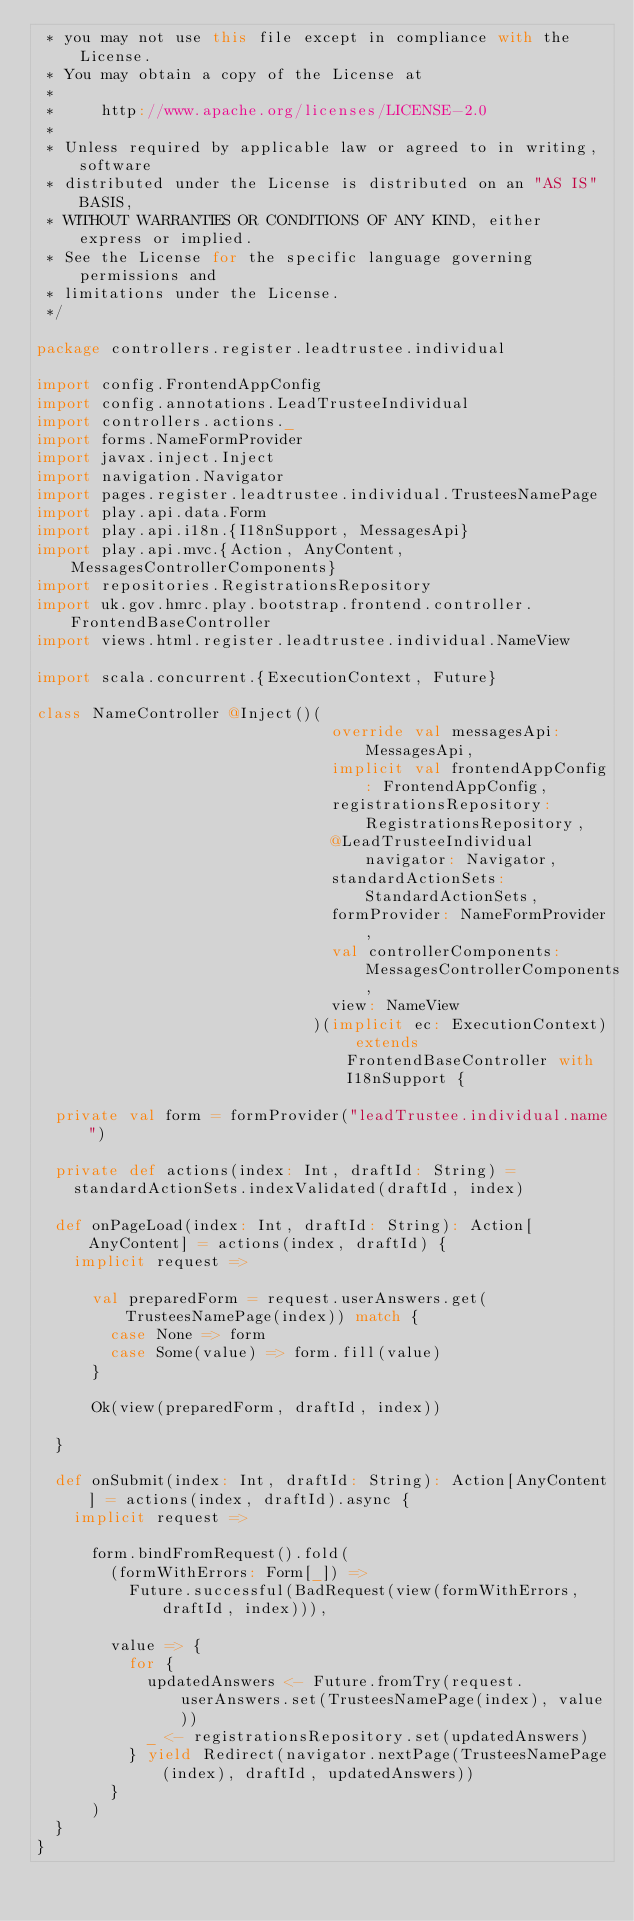Convert code to text. <code><loc_0><loc_0><loc_500><loc_500><_Scala_> * you may not use this file except in compliance with the License.
 * You may obtain a copy of the License at
 *
 *     http://www.apache.org/licenses/LICENSE-2.0
 *
 * Unless required by applicable law or agreed to in writing, software
 * distributed under the License is distributed on an "AS IS" BASIS,
 * WITHOUT WARRANTIES OR CONDITIONS OF ANY KIND, either express or implied.
 * See the License for the specific language governing permissions and
 * limitations under the License.
 */

package controllers.register.leadtrustee.individual

import config.FrontendAppConfig
import config.annotations.LeadTrusteeIndividual
import controllers.actions._
import forms.NameFormProvider
import javax.inject.Inject
import navigation.Navigator
import pages.register.leadtrustee.individual.TrusteesNamePage
import play.api.data.Form
import play.api.i18n.{I18nSupport, MessagesApi}
import play.api.mvc.{Action, AnyContent, MessagesControllerComponents}
import repositories.RegistrationsRepository
import uk.gov.hmrc.play.bootstrap.frontend.controller.FrontendBaseController
import views.html.register.leadtrustee.individual.NameView

import scala.concurrent.{ExecutionContext, Future}

class NameController @Inject()(
                                override val messagesApi: MessagesApi,
                                implicit val frontendAppConfig: FrontendAppConfig,
                                registrationsRepository: RegistrationsRepository,
                                @LeadTrusteeIndividual navigator: Navigator,
                                standardActionSets: StandardActionSets,
                                formProvider: NameFormProvider,
                                val controllerComponents: MessagesControllerComponents,
                                view: NameView
                              )(implicit ec: ExecutionContext) extends FrontendBaseController with I18nSupport {

  private val form = formProvider("leadTrustee.individual.name")

  private def actions(index: Int, draftId: String) =
    standardActionSets.indexValidated(draftId, index)

  def onPageLoad(index: Int, draftId: String): Action[AnyContent] = actions(index, draftId) {
    implicit request =>

      val preparedForm = request.userAnswers.get(TrusteesNamePage(index)) match {
        case None => form
        case Some(value) => form.fill(value)
      }

      Ok(view(preparedForm, draftId, index))

  }

  def onSubmit(index: Int, draftId: String): Action[AnyContent] = actions(index, draftId).async {
    implicit request =>

      form.bindFromRequest().fold(
        (formWithErrors: Form[_]) =>
          Future.successful(BadRequest(view(formWithErrors, draftId, index))),

        value => {
          for {
            updatedAnswers <- Future.fromTry(request.userAnswers.set(TrusteesNamePage(index), value))
            _ <- registrationsRepository.set(updatedAnswers)
          } yield Redirect(navigator.nextPage(TrusteesNamePage(index), draftId, updatedAnswers))
        }
      )
  }
}
</code> 